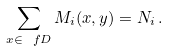<formula> <loc_0><loc_0><loc_500><loc_500>\sum _ { x \in \ f D } M _ { i } ( x , y ) = N _ { i } \, .</formula> 